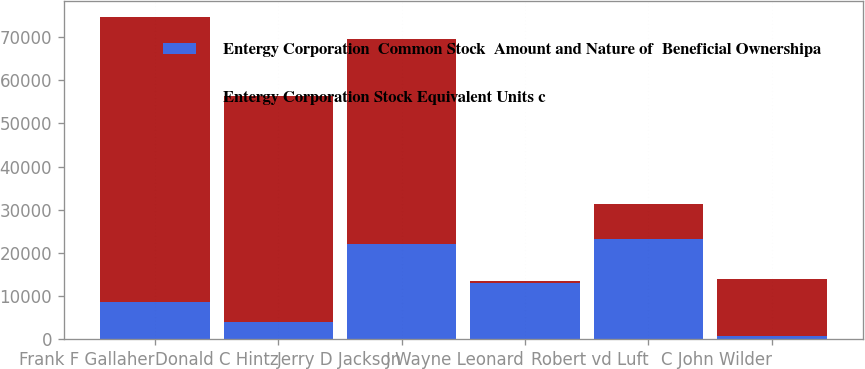Convert chart. <chart><loc_0><loc_0><loc_500><loc_500><stacked_bar_chart><ecel><fcel>Frank F Gallaher<fcel>Donald C Hintz<fcel>Jerry D Jackson<fcel>J Wayne Leonard<fcel>Robert vd Luft<fcel>C John Wilder<nl><fcel>Entergy Corporation  Common Stock  Amount and Nature of  Beneficial Ownershipa<fcel>8519<fcel>4055<fcel>22083<fcel>13065<fcel>23272<fcel>798<nl><fcel>Entergy Corporation Stock Equivalent Units c<fcel>66097<fcel>52192<fcel>47374<fcel>496<fcel>8000<fcel>13065<nl></chart> 